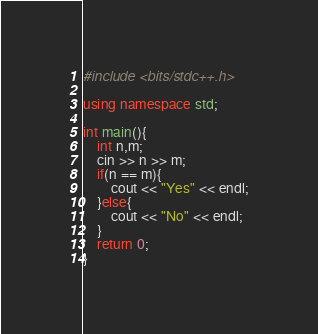<code> <loc_0><loc_0><loc_500><loc_500><_C++_>#include <bits/stdc++.h>

using namespace std;

int main(){
    int n,m;
    cin >> n >> m;
    if(n == m){
        cout << "Yes" << endl;
    }else{
        cout << "No" << endl;
    }
    return 0;
}</code> 